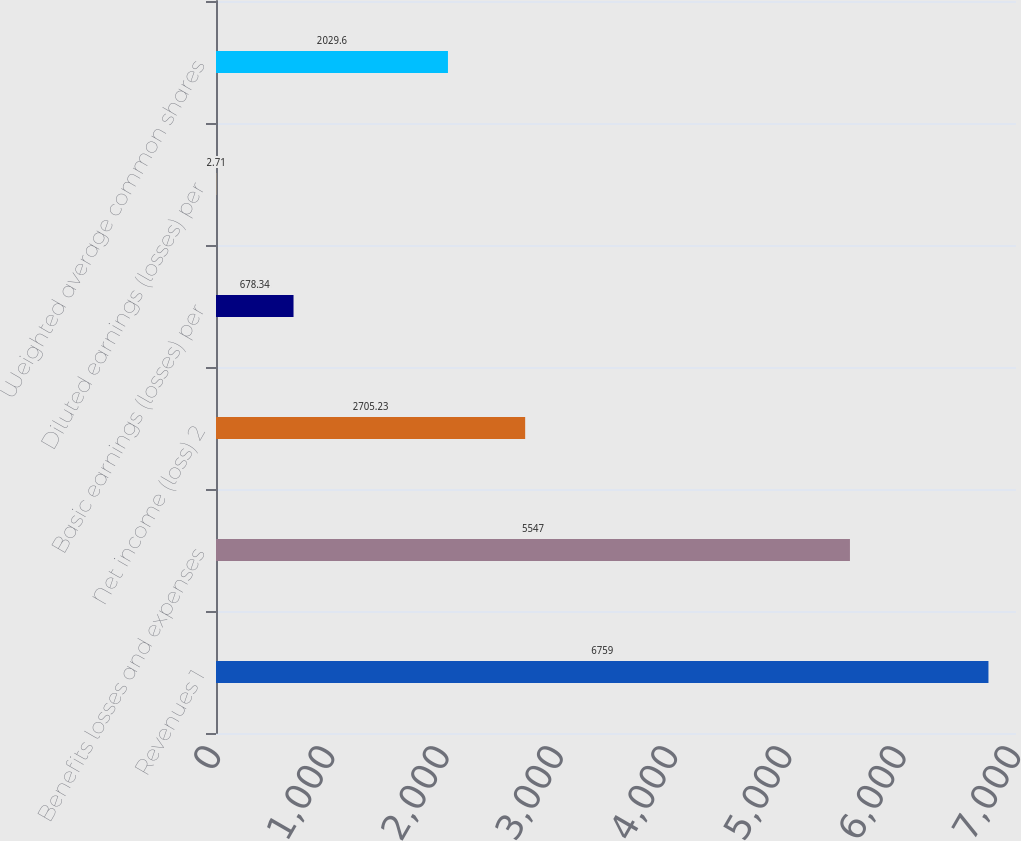Convert chart. <chart><loc_0><loc_0><loc_500><loc_500><bar_chart><fcel>Revenues 1<fcel>Benefits losses and expenses<fcel>Net income (loss) 2<fcel>Basic earnings (losses) per<fcel>Diluted earnings (losses) per<fcel>Weighted average common shares<nl><fcel>6759<fcel>5547<fcel>2705.23<fcel>678.34<fcel>2.71<fcel>2029.6<nl></chart> 